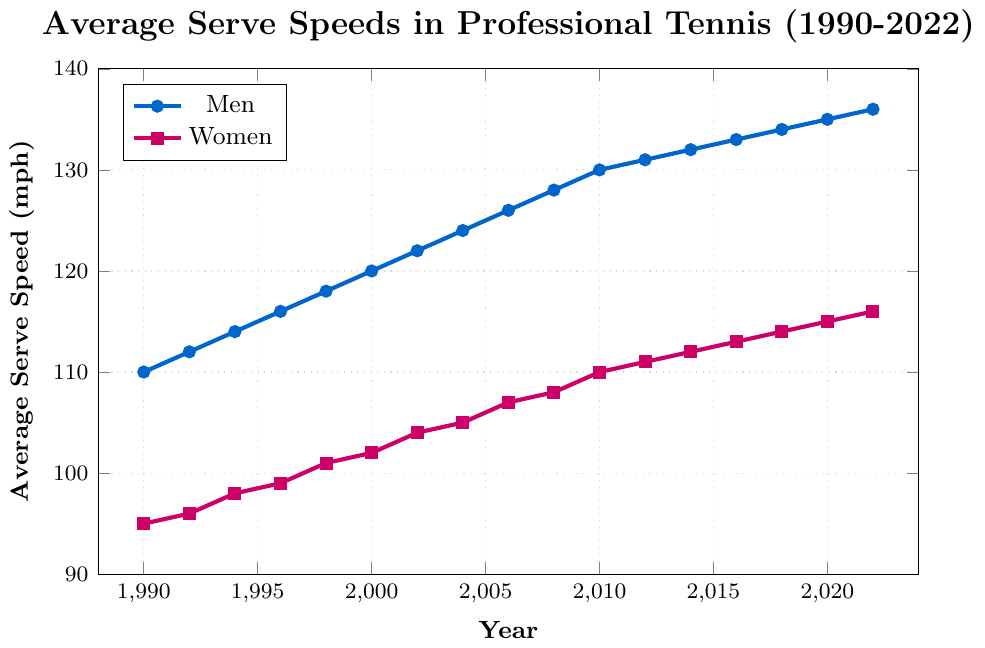Which year saw the highest average serve speed for men? The highest average serve speed for men can be determined by looking at the peak value on the men's serve speed line. The peak value occurs at the rightmost point of the line. From the figure, this peak value is at 2022 with a speed of 136 mph.
Answer: 2022 What is the difference in average serve speed between men and women in 2022? To find the difference, subtract the women’s average serve speed in 2022 from the men’s average serve speed in 2022. For 2022, men’s speed is 136 mph and women’s speed is 116 mph. Therefore, the difference is 136 mph - 116 mph = 20 mph.
Answer: 20 mph In which year did women reach an average serve speed of 100 mph or more for the first time? Locate the points on the women's serve speed line and find the first point where the value is 100 mph or more. The chart shows that it was in 1998 when the speed was 101 mph.
Answer: 1998 How many years did it take for men's average serve speed to increase from 120 mph to 130 mph? Identify the years when the average serve speed was 120 mph and 130 mph for men. In the chart, 120 mph occurs in 2000 and 130 mph occurs in 2010. The difference between 2010 and 2000 is 10 years.
Answer: 10 years What is the average serve speed for men in 2000? Read the value of the men's average serve speed from the plot in 2000. From the figure, it is 120 mph.
Answer: 120 mph Which gender showed a greater increase in average serve speed from 1990 to 2022? Find the increase for each gender by subtracting the 1990 value from the 2022 value. Men’s serve increased from 110 mph in 1990 to 136 mph in 2022, which is an increase of 26 mph. Women’s serve increased from 95 mph in 1990 to 116 mph in 2022, which is an increase of 21 mph. Since 26 mph > 21 mph, men showed a greater increase.
Answer: Men By how much did the average serve speed for women increase from 1994 to 2004? Subtract the average serve speed of women in 1994 from that in 2004. From the chart, the values are 98 mph in 1994 and 105 mph in 2004. The increase is 105 mph - 98 mph = 7 mph.
Answer: 7 mph What color represents women's average serve speed on the chart? Identify the color used for the women's line and markers in the chart. The women's average serve speed is marked with a magenta or purple line and square markers.
Answer: Magenta (or purple) Which year had the smallest gap between men’s and women’s average serve speeds, and what was the gap? Calculate the gap for each year by subtracting women's speeds from men's speeds and find the smallest gap. The smallest gap is in 1990 with a difference of 15 mph (110 mph - 95 mph).
Answer: 1990, 15 mph How does the trend of the average serve speeds change over time for both men and women? Describe the overall direction and pattern of the serve speed lines over the years. Both men's and women's average serve speeds steadily increased over time from 1990 to 2022.
Answer: Both increased steadily 